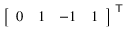<formula> <loc_0><loc_0><loc_500><loc_500>{ \left [ \begin{array} { l l l l } { 0 } & { 1 } & { - 1 } & { 1 } \end{array} \right ] } ^ { T }</formula> 